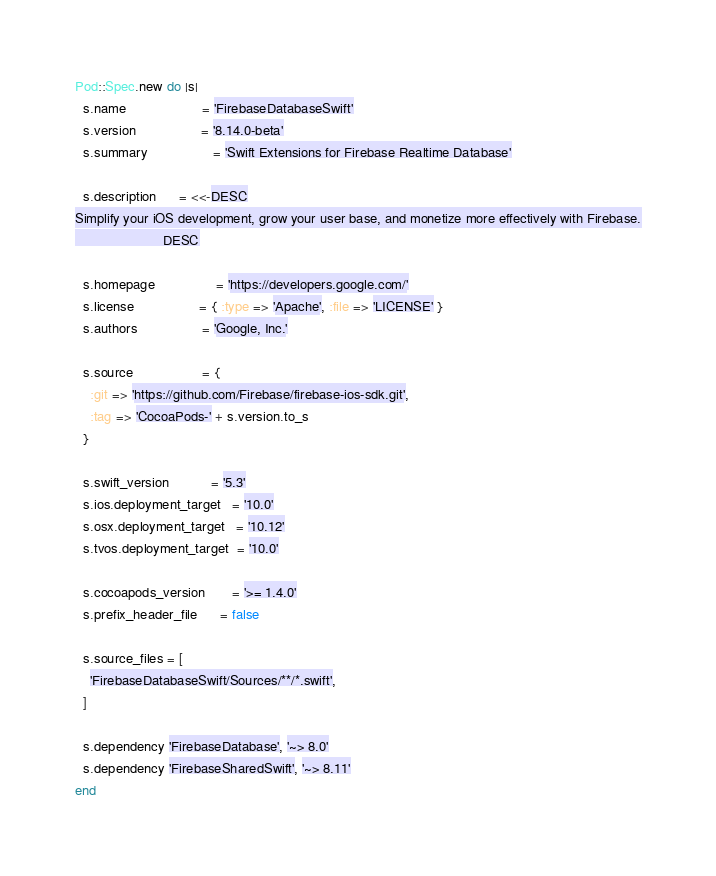Convert code to text. <code><loc_0><loc_0><loc_500><loc_500><_Ruby_>Pod::Spec.new do |s|
  s.name                    = 'FirebaseDatabaseSwift'
  s.version                 = '8.14.0-beta'
  s.summary                 = 'Swift Extensions for Firebase Realtime Database'

  s.description      = <<-DESC
Simplify your iOS development, grow your user base, and monetize more effectively with Firebase.
                       DESC

  s.homepage                = 'https://developers.google.com/'
  s.license                 = { :type => 'Apache', :file => 'LICENSE' }
  s.authors                 = 'Google, Inc.'

  s.source                  = {
    :git => 'https://github.com/Firebase/firebase-ios-sdk.git',
    :tag => 'CocoaPods-' + s.version.to_s
  }

  s.swift_version           = '5.3'
  s.ios.deployment_target   = '10.0'
  s.osx.deployment_target   = '10.12'
  s.tvos.deployment_target  = '10.0'

  s.cocoapods_version       = '>= 1.4.0'
  s.prefix_header_file      = false

  s.source_files = [
    'FirebaseDatabaseSwift/Sources/**/*.swift',
  ]

  s.dependency 'FirebaseDatabase', '~> 8.0'
  s.dependency 'FirebaseSharedSwift', '~> 8.11'
end
</code> 